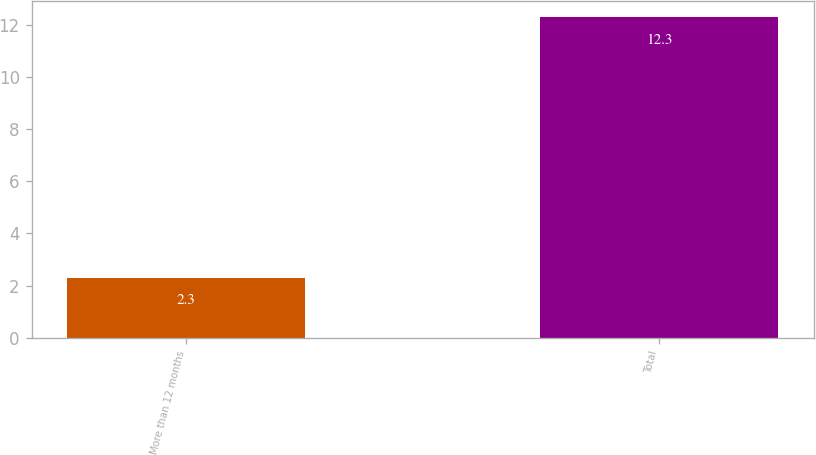Convert chart. <chart><loc_0><loc_0><loc_500><loc_500><bar_chart><fcel>More than 12 months<fcel>Total<nl><fcel>2.3<fcel>12.3<nl></chart> 